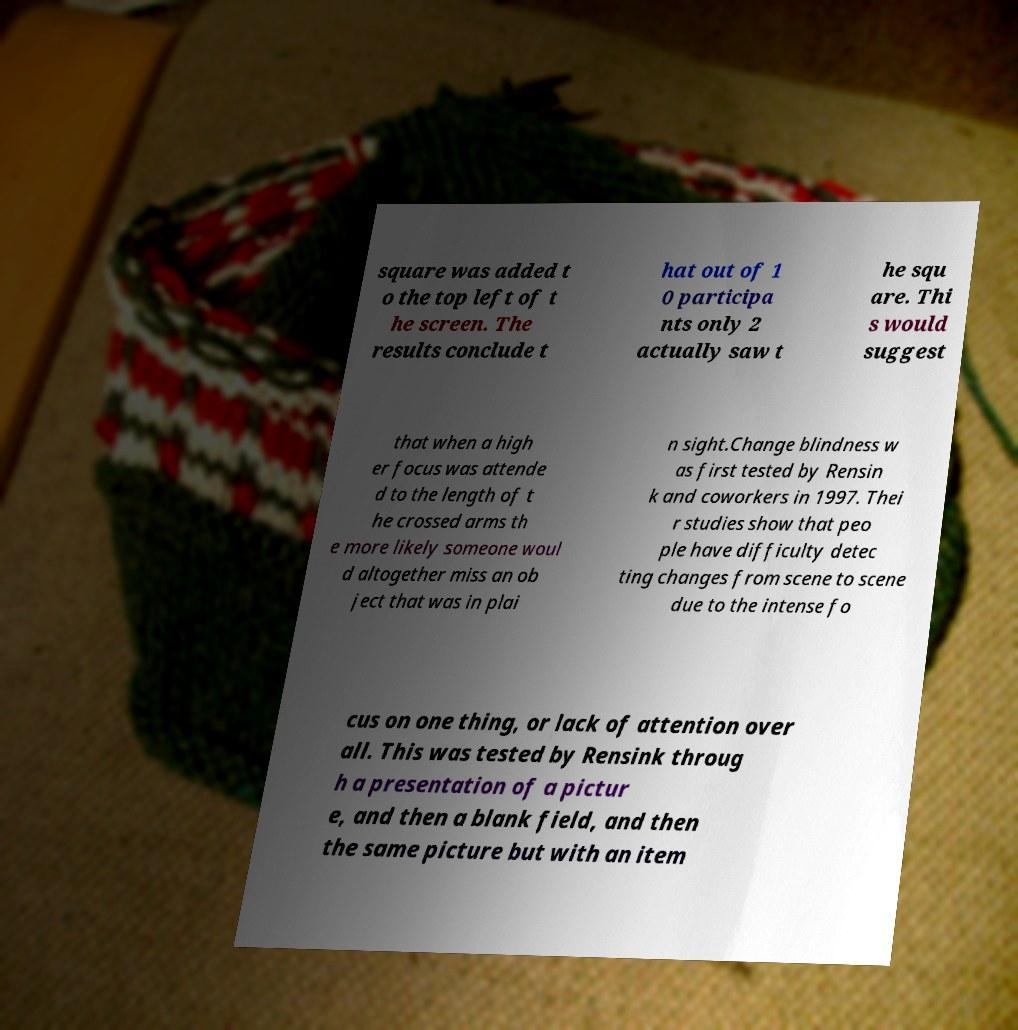Please read and relay the text visible in this image. What does it say? square was added t o the top left of t he screen. The results conclude t hat out of 1 0 participa nts only 2 actually saw t he squ are. Thi s would suggest that when a high er focus was attende d to the length of t he crossed arms th e more likely someone woul d altogether miss an ob ject that was in plai n sight.Change blindness w as first tested by Rensin k and coworkers in 1997. Thei r studies show that peo ple have difficulty detec ting changes from scene to scene due to the intense fo cus on one thing, or lack of attention over all. This was tested by Rensink throug h a presentation of a pictur e, and then a blank field, and then the same picture but with an item 